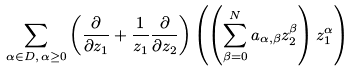Convert formula to latex. <formula><loc_0><loc_0><loc_500><loc_500>\sum _ { \alpha \in D , \, \alpha \geq 0 } \left ( \frac { \partial } { \partial z _ { 1 } } + \frac { 1 } { z _ { 1 } } \frac { \partial } { \partial z _ { 2 } } \right ) \left ( \left ( \sum _ { \beta = 0 } ^ { N } a _ { \alpha , \beta } z _ { 2 } ^ { \beta } \right ) z _ { 1 } ^ { \alpha } \right )</formula> 